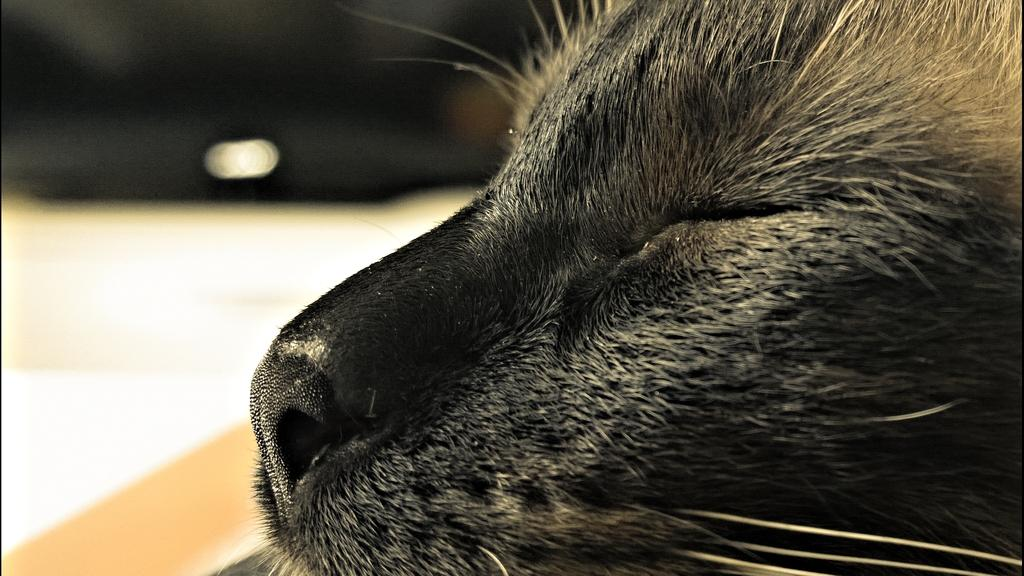What type of animal is in the image? There is a black cat in the image. How close is the view of the cat in the image? The image is a close-up view of the cat. What can be observed about the background in the image? The background of the image is blurred. What type of tin is the cat holding in the image? There is no tin present in the image; it features a black cat with a blurred background. What direction is the current flowing in the image? There is no current present in the image; it features a black cat with a blurred background. 